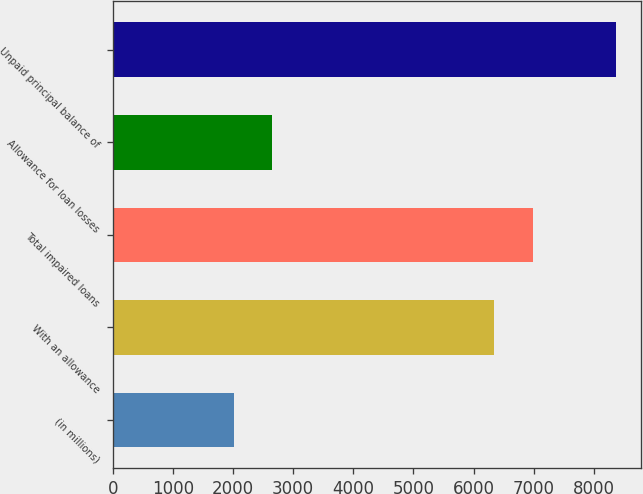Convert chart. <chart><loc_0><loc_0><loc_500><loc_500><bar_chart><fcel>(in millions)<fcel>With an allowance<fcel>Total impaired loans<fcel>Allowance for loan losses<fcel>Unpaid principal balance of<nl><fcel>2009<fcel>6347<fcel>6983.4<fcel>2645.4<fcel>8373<nl></chart> 